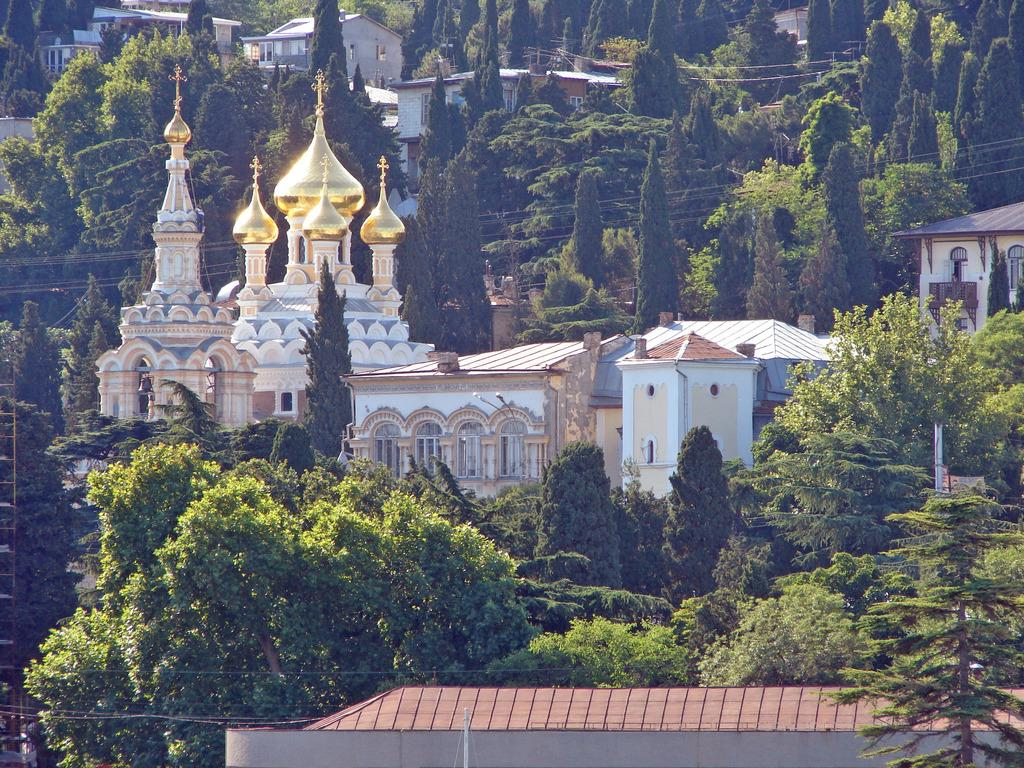What type of natural elements can be seen in the image? There are trees in the image. What type of man-made structures are present in the image? There are buildings in the image. What type of infrastructure can be seen in the image? There are wires on the bottom side and in the center of the image. Can you see any cows in the image? There are no cows present in the image. What type of smoke can be seen coming from the buildings in the image? There is no smoke visible in the image; only trees, buildings, and wires are present. 